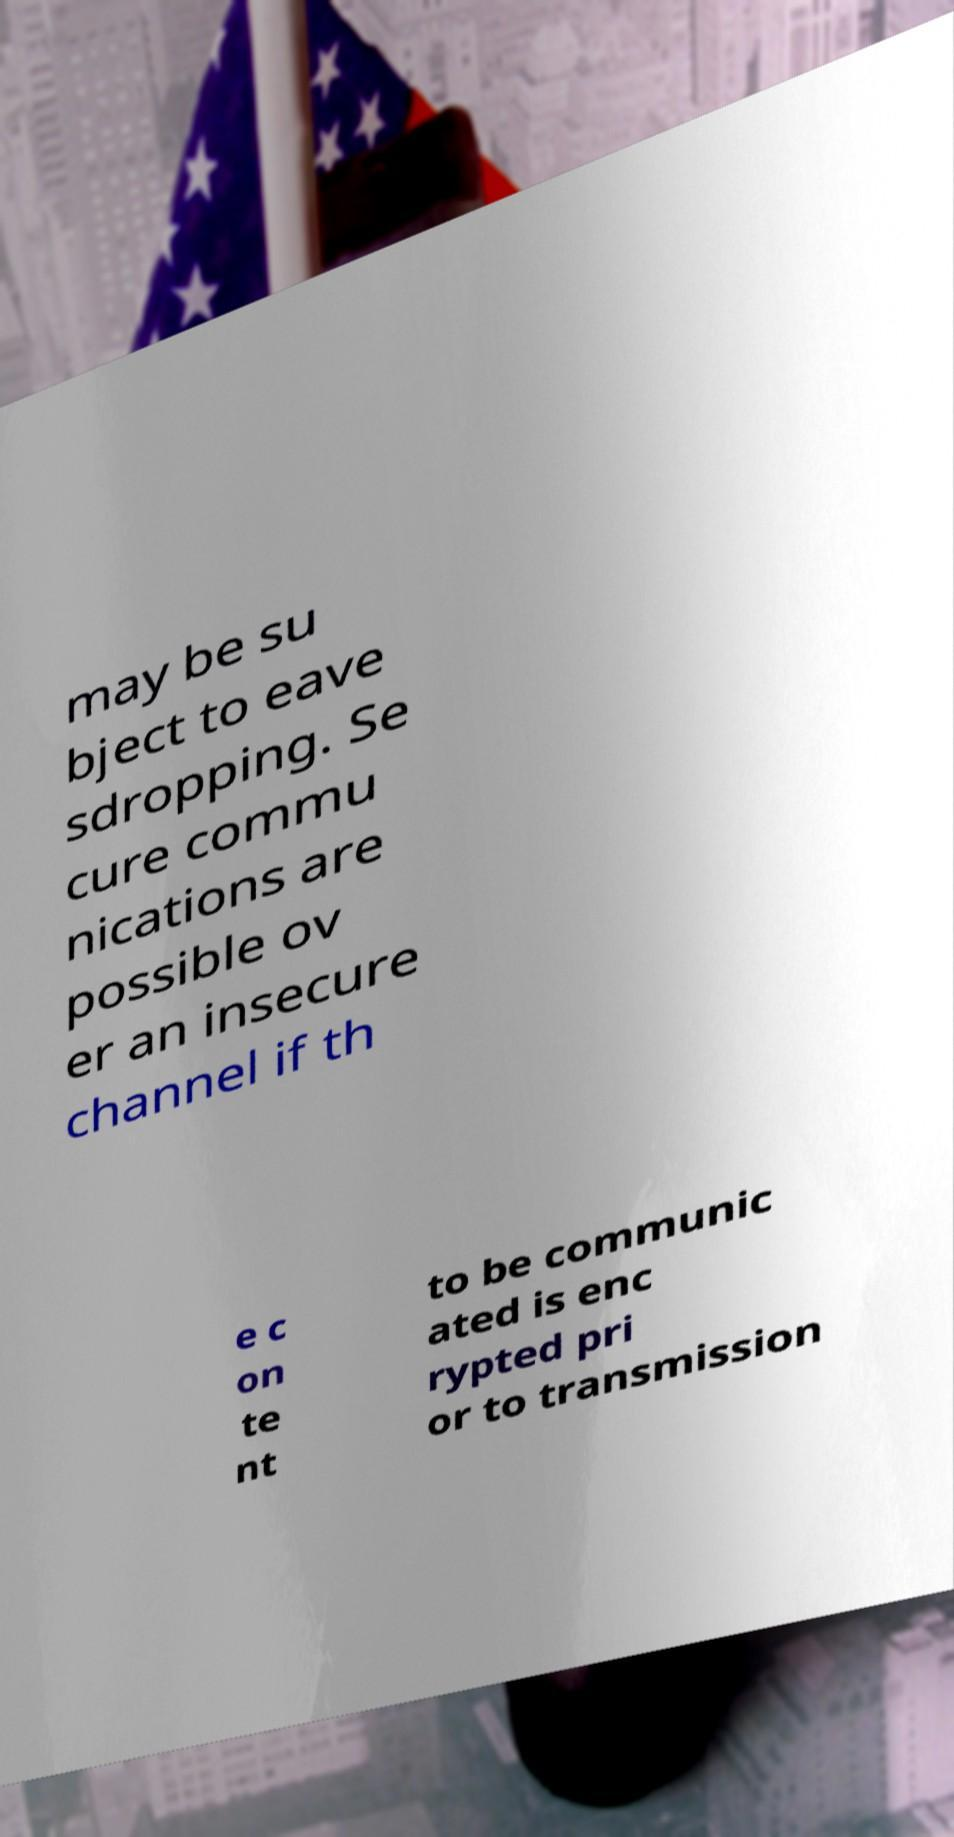Please read and relay the text visible in this image. What does it say? may be su bject to eave sdropping. Se cure commu nications are possible ov er an insecure channel if th e c on te nt to be communic ated is enc rypted pri or to transmission 